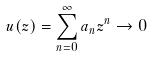Convert formula to latex. <formula><loc_0><loc_0><loc_500><loc_500>u ( z ) = \sum _ { n = 0 } ^ { \infty } a _ { n } z ^ { n } \rightarrow 0</formula> 